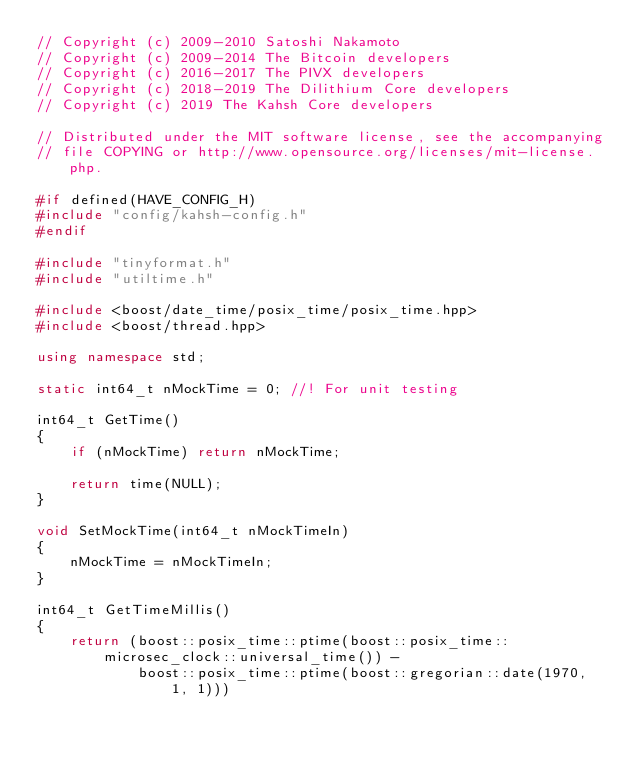<code> <loc_0><loc_0><loc_500><loc_500><_C++_>// Copyright (c) 2009-2010 Satoshi Nakamoto
// Copyright (c) 2009-2014 The Bitcoin developers
// Copyright (c) 2016-2017 The PIVX developers
// Copyright (c) 2018-2019 The Dilithium Core developers
// Copyright (c) 2019 The Kahsh Core developers

// Distributed under the MIT software license, see the accompanying
// file COPYING or http://www.opensource.org/licenses/mit-license.php.

#if defined(HAVE_CONFIG_H)
#include "config/kahsh-config.h"
#endif

#include "tinyformat.h"
#include "utiltime.h"

#include <boost/date_time/posix_time/posix_time.hpp>
#include <boost/thread.hpp>

using namespace std;

static int64_t nMockTime = 0; //! For unit testing

int64_t GetTime()
{
    if (nMockTime) return nMockTime;

    return time(NULL);
}

void SetMockTime(int64_t nMockTimeIn)
{
    nMockTime = nMockTimeIn;
}

int64_t GetTimeMillis()
{
    return (boost::posix_time::ptime(boost::posix_time::microsec_clock::universal_time()) -
            boost::posix_time::ptime(boost::gregorian::date(1970, 1, 1)))</code> 